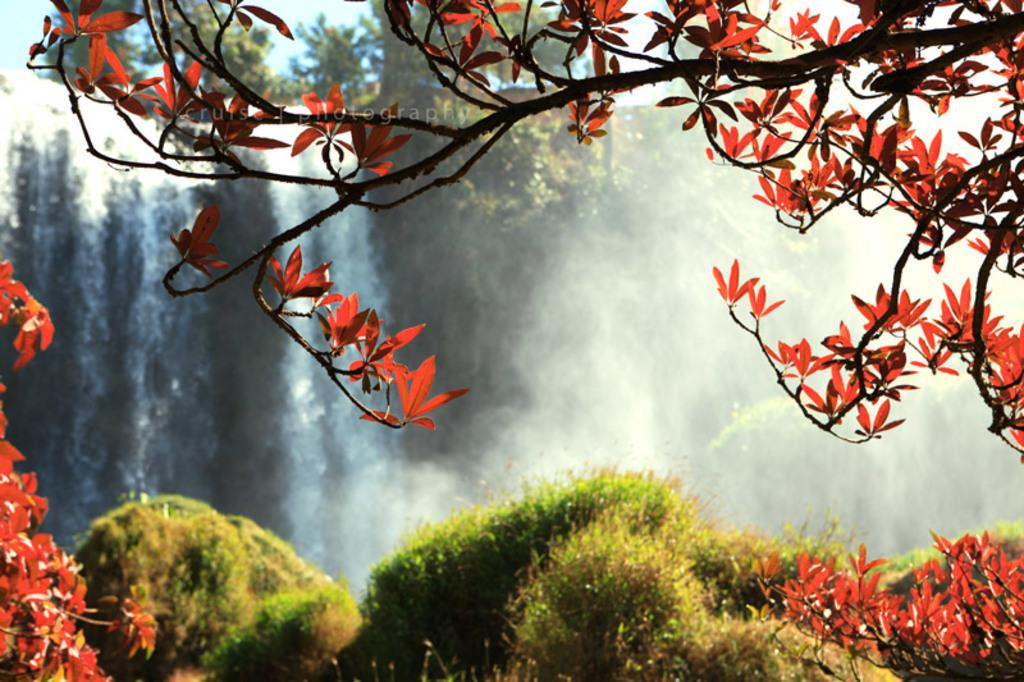What type of vegetation can be seen in the image? There are plants and trees in the image. What natural feature is present in the image? There is a waterfall in the image. What part of the natural environment is visible in the image? The sky is visible in the image. What type of location might the image depict? The image may have been taken near a hill station. What type of horn can be seen on the waterfall in the image? There is no horn present on the waterfall in the image. What substance is being treated in the image? There is no substance being treated in the image; it is a natural scene featuring plants, trees, a waterfall, and the sky. 